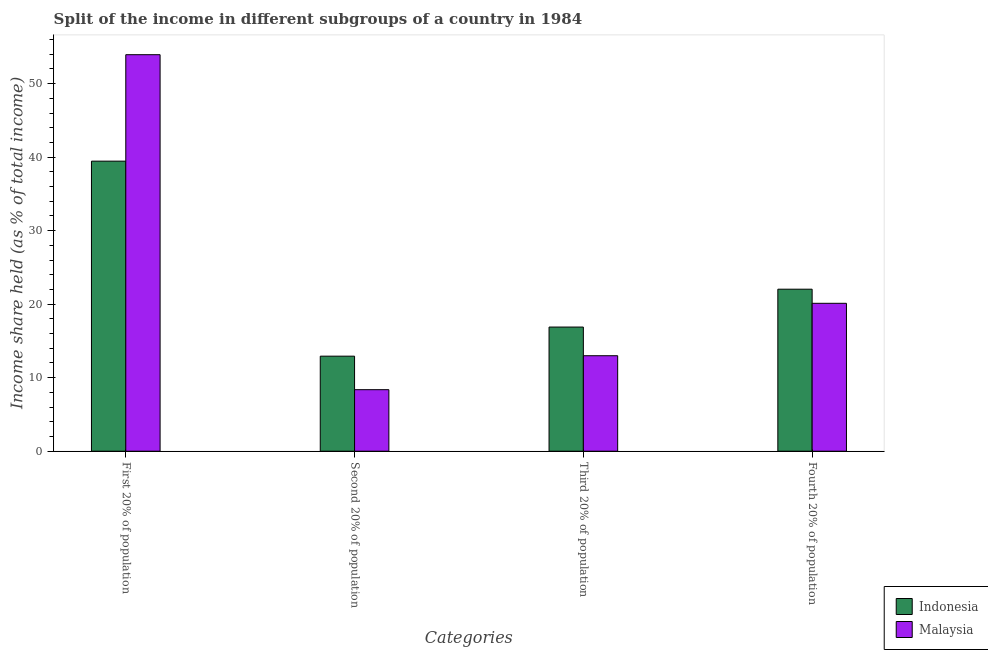How many groups of bars are there?
Your answer should be very brief. 4. Are the number of bars on each tick of the X-axis equal?
Offer a very short reply. Yes. What is the label of the 3rd group of bars from the left?
Your answer should be compact. Third 20% of population. What is the share of the income held by second 20% of the population in Indonesia?
Your answer should be compact. 12.93. Across all countries, what is the maximum share of the income held by third 20% of the population?
Make the answer very short. 16.89. Across all countries, what is the minimum share of the income held by first 20% of the population?
Make the answer very short. 39.46. In which country was the share of the income held by first 20% of the population maximum?
Your response must be concise. Malaysia. In which country was the share of the income held by first 20% of the population minimum?
Offer a very short reply. Indonesia. What is the total share of the income held by third 20% of the population in the graph?
Provide a succinct answer. 29.88. What is the difference between the share of the income held by third 20% of the population in Indonesia and that in Malaysia?
Keep it short and to the point. 3.9. What is the difference between the share of the income held by first 20% of the population in Indonesia and the share of the income held by third 20% of the population in Malaysia?
Your response must be concise. 26.47. What is the average share of the income held by first 20% of the population per country?
Provide a short and direct response. 46.7. What is the difference between the share of the income held by fourth 20% of the population and share of the income held by second 20% of the population in Malaysia?
Your answer should be compact. 11.75. In how many countries, is the share of the income held by second 20% of the population greater than 28 %?
Provide a short and direct response. 0. What is the ratio of the share of the income held by first 20% of the population in Indonesia to that in Malaysia?
Provide a short and direct response. 0.73. What is the difference between the highest and the second highest share of the income held by third 20% of the population?
Give a very brief answer. 3.9. What is the difference between the highest and the lowest share of the income held by fourth 20% of the population?
Provide a short and direct response. 1.92. In how many countries, is the share of the income held by third 20% of the population greater than the average share of the income held by third 20% of the population taken over all countries?
Keep it short and to the point. 1. What does the 1st bar from the right in Fourth 20% of population represents?
Your answer should be very brief. Malaysia. How many bars are there?
Make the answer very short. 8. Are the values on the major ticks of Y-axis written in scientific E-notation?
Ensure brevity in your answer.  No. Does the graph contain grids?
Your response must be concise. No. Where does the legend appear in the graph?
Offer a very short reply. Bottom right. What is the title of the graph?
Keep it short and to the point. Split of the income in different subgroups of a country in 1984. What is the label or title of the X-axis?
Provide a short and direct response. Categories. What is the label or title of the Y-axis?
Make the answer very short. Income share held (as % of total income). What is the Income share held (as % of total income) of Indonesia in First 20% of population?
Keep it short and to the point. 39.46. What is the Income share held (as % of total income) in Malaysia in First 20% of population?
Your answer should be very brief. 53.94. What is the Income share held (as % of total income) of Indonesia in Second 20% of population?
Offer a terse response. 12.93. What is the Income share held (as % of total income) of Malaysia in Second 20% of population?
Your response must be concise. 8.37. What is the Income share held (as % of total income) of Indonesia in Third 20% of population?
Your answer should be compact. 16.89. What is the Income share held (as % of total income) in Malaysia in Third 20% of population?
Keep it short and to the point. 12.99. What is the Income share held (as % of total income) in Indonesia in Fourth 20% of population?
Provide a succinct answer. 22.04. What is the Income share held (as % of total income) of Malaysia in Fourth 20% of population?
Provide a succinct answer. 20.12. Across all Categories, what is the maximum Income share held (as % of total income) in Indonesia?
Provide a short and direct response. 39.46. Across all Categories, what is the maximum Income share held (as % of total income) in Malaysia?
Keep it short and to the point. 53.94. Across all Categories, what is the minimum Income share held (as % of total income) of Indonesia?
Give a very brief answer. 12.93. Across all Categories, what is the minimum Income share held (as % of total income) in Malaysia?
Give a very brief answer. 8.37. What is the total Income share held (as % of total income) in Indonesia in the graph?
Offer a very short reply. 91.32. What is the total Income share held (as % of total income) of Malaysia in the graph?
Your response must be concise. 95.42. What is the difference between the Income share held (as % of total income) of Indonesia in First 20% of population and that in Second 20% of population?
Ensure brevity in your answer.  26.53. What is the difference between the Income share held (as % of total income) of Malaysia in First 20% of population and that in Second 20% of population?
Give a very brief answer. 45.57. What is the difference between the Income share held (as % of total income) of Indonesia in First 20% of population and that in Third 20% of population?
Your answer should be compact. 22.57. What is the difference between the Income share held (as % of total income) in Malaysia in First 20% of population and that in Third 20% of population?
Ensure brevity in your answer.  40.95. What is the difference between the Income share held (as % of total income) in Indonesia in First 20% of population and that in Fourth 20% of population?
Make the answer very short. 17.42. What is the difference between the Income share held (as % of total income) in Malaysia in First 20% of population and that in Fourth 20% of population?
Offer a very short reply. 33.82. What is the difference between the Income share held (as % of total income) of Indonesia in Second 20% of population and that in Third 20% of population?
Your response must be concise. -3.96. What is the difference between the Income share held (as % of total income) of Malaysia in Second 20% of population and that in Third 20% of population?
Provide a succinct answer. -4.62. What is the difference between the Income share held (as % of total income) in Indonesia in Second 20% of population and that in Fourth 20% of population?
Keep it short and to the point. -9.11. What is the difference between the Income share held (as % of total income) in Malaysia in Second 20% of population and that in Fourth 20% of population?
Ensure brevity in your answer.  -11.75. What is the difference between the Income share held (as % of total income) of Indonesia in Third 20% of population and that in Fourth 20% of population?
Keep it short and to the point. -5.15. What is the difference between the Income share held (as % of total income) of Malaysia in Third 20% of population and that in Fourth 20% of population?
Make the answer very short. -7.13. What is the difference between the Income share held (as % of total income) in Indonesia in First 20% of population and the Income share held (as % of total income) in Malaysia in Second 20% of population?
Provide a short and direct response. 31.09. What is the difference between the Income share held (as % of total income) in Indonesia in First 20% of population and the Income share held (as % of total income) in Malaysia in Third 20% of population?
Your answer should be compact. 26.47. What is the difference between the Income share held (as % of total income) in Indonesia in First 20% of population and the Income share held (as % of total income) in Malaysia in Fourth 20% of population?
Give a very brief answer. 19.34. What is the difference between the Income share held (as % of total income) in Indonesia in Second 20% of population and the Income share held (as % of total income) in Malaysia in Third 20% of population?
Keep it short and to the point. -0.06. What is the difference between the Income share held (as % of total income) in Indonesia in Second 20% of population and the Income share held (as % of total income) in Malaysia in Fourth 20% of population?
Provide a succinct answer. -7.19. What is the difference between the Income share held (as % of total income) of Indonesia in Third 20% of population and the Income share held (as % of total income) of Malaysia in Fourth 20% of population?
Ensure brevity in your answer.  -3.23. What is the average Income share held (as % of total income) of Indonesia per Categories?
Provide a short and direct response. 22.83. What is the average Income share held (as % of total income) of Malaysia per Categories?
Keep it short and to the point. 23.86. What is the difference between the Income share held (as % of total income) of Indonesia and Income share held (as % of total income) of Malaysia in First 20% of population?
Make the answer very short. -14.48. What is the difference between the Income share held (as % of total income) in Indonesia and Income share held (as % of total income) in Malaysia in Second 20% of population?
Your answer should be compact. 4.56. What is the difference between the Income share held (as % of total income) of Indonesia and Income share held (as % of total income) of Malaysia in Third 20% of population?
Provide a short and direct response. 3.9. What is the difference between the Income share held (as % of total income) of Indonesia and Income share held (as % of total income) of Malaysia in Fourth 20% of population?
Your answer should be compact. 1.92. What is the ratio of the Income share held (as % of total income) in Indonesia in First 20% of population to that in Second 20% of population?
Offer a terse response. 3.05. What is the ratio of the Income share held (as % of total income) in Malaysia in First 20% of population to that in Second 20% of population?
Provide a short and direct response. 6.44. What is the ratio of the Income share held (as % of total income) in Indonesia in First 20% of population to that in Third 20% of population?
Make the answer very short. 2.34. What is the ratio of the Income share held (as % of total income) in Malaysia in First 20% of population to that in Third 20% of population?
Make the answer very short. 4.15. What is the ratio of the Income share held (as % of total income) of Indonesia in First 20% of population to that in Fourth 20% of population?
Your answer should be compact. 1.79. What is the ratio of the Income share held (as % of total income) in Malaysia in First 20% of population to that in Fourth 20% of population?
Your answer should be compact. 2.68. What is the ratio of the Income share held (as % of total income) of Indonesia in Second 20% of population to that in Third 20% of population?
Your answer should be compact. 0.77. What is the ratio of the Income share held (as % of total income) in Malaysia in Second 20% of population to that in Third 20% of population?
Provide a succinct answer. 0.64. What is the ratio of the Income share held (as % of total income) in Indonesia in Second 20% of population to that in Fourth 20% of population?
Provide a short and direct response. 0.59. What is the ratio of the Income share held (as % of total income) of Malaysia in Second 20% of population to that in Fourth 20% of population?
Provide a short and direct response. 0.42. What is the ratio of the Income share held (as % of total income) of Indonesia in Third 20% of population to that in Fourth 20% of population?
Offer a very short reply. 0.77. What is the ratio of the Income share held (as % of total income) of Malaysia in Third 20% of population to that in Fourth 20% of population?
Your response must be concise. 0.65. What is the difference between the highest and the second highest Income share held (as % of total income) in Indonesia?
Keep it short and to the point. 17.42. What is the difference between the highest and the second highest Income share held (as % of total income) in Malaysia?
Give a very brief answer. 33.82. What is the difference between the highest and the lowest Income share held (as % of total income) of Indonesia?
Your answer should be very brief. 26.53. What is the difference between the highest and the lowest Income share held (as % of total income) in Malaysia?
Keep it short and to the point. 45.57. 